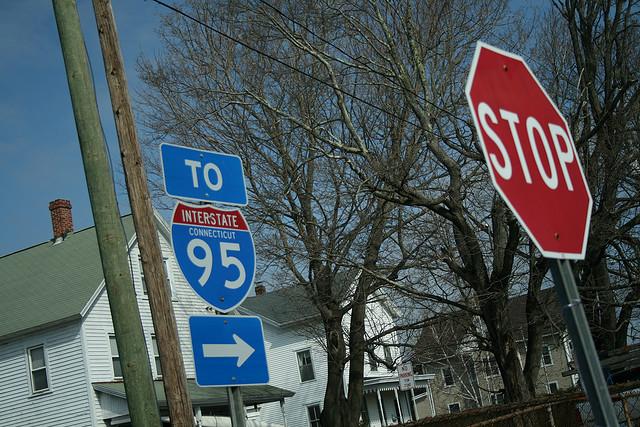Is this in America?
Concise answer only. Yes. What type of road is advertised?
Keep it brief. Interstate. What color is the sign to the left?
Short answer required. Blue. 